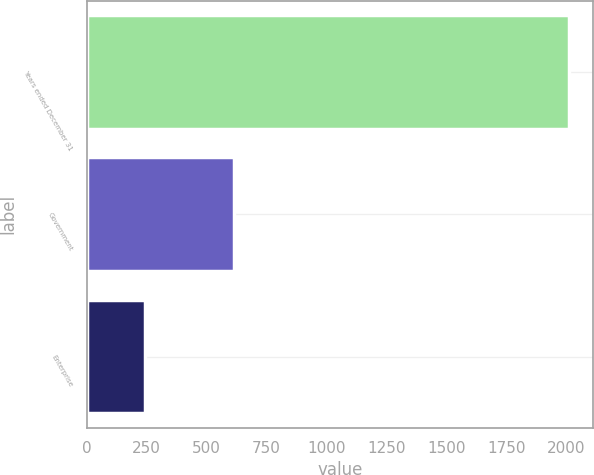Convert chart. <chart><loc_0><loc_0><loc_500><loc_500><bar_chart><fcel>Years ended December 31<fcel>Government<fcel>Enterprise<nl><fcel>2011<fcel>616<fcel>242<nl></chart> 